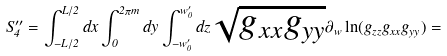<formula> <loc_0><loc_0><loc_500><loc_500>S ^ { \prime \prime } _ { 4 } = \int ^ { L / 2 } _ { - L / 2 } d x \int ^ { 2 \pi m } _ { 0 } d y \int ^ { w ^ { \prime } _ { 0 } } _ { - w ^ { \prime } _ { 0 } } d z \sqrt { g _ { x x } g _ { y y } } \partial _ { w } \ln ( g _ { z z } g _ { x x } g _ { y y } ) =</formula> 